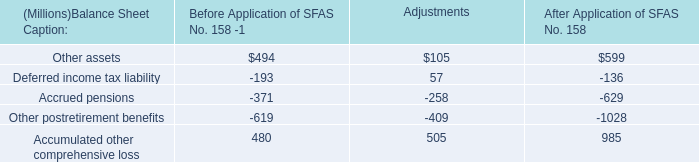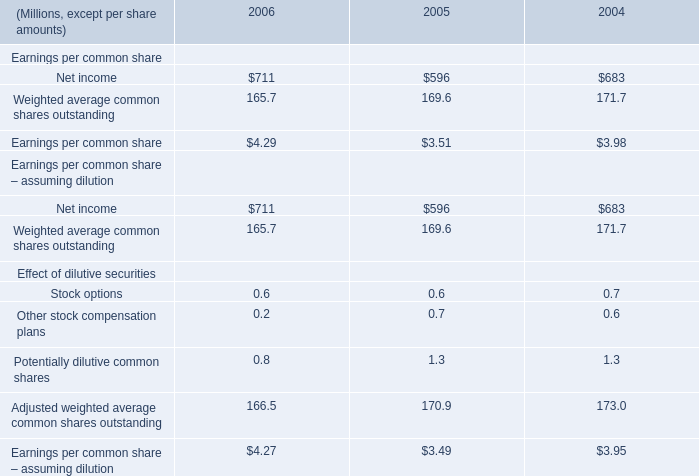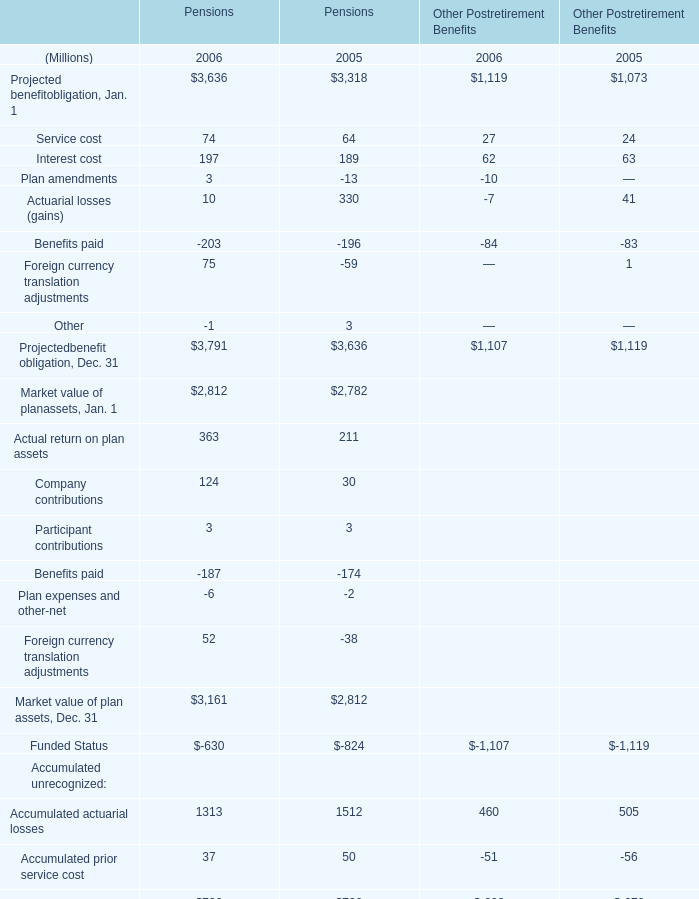what was the change in millions in the reserve for product warranties from 2005 to 2006? 
Computations: (10 - 4)
Answer: 6.0. 